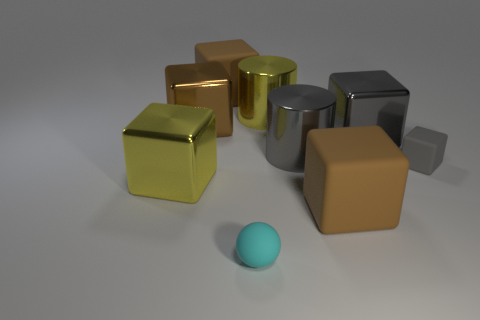Is the material of the large yellow object right of the cyan matte sphere the same as the sphere?
Offer a terse response. No. The small matte object in front of the big brown rubber block that is in front of the yellow shiny thing that is behind the small gray matte object is what shape?
Offer a very short reply. Sphere. How many brown objects are spheres or blocks?
Offer a very short reply. 3. Are there the same number of large yellow cylinders in front of the yellow shiny cylinder and balls that are behind the small gray block?
Ensure brevity in your answer.  Yes. Does the gray metal thing left of the large gray cube have the same shape as the big rubber thing that is in front of the yellow metallic cylinder?
Offer a very short reply. No. Is there any other thing that has the same shape as the tiny cyan thing?
Your answer should be very brief. No. The yellow object that is the same material as the yellow cylinder is what shape?
Keep it short and to the point. Cube. Are there the same number of big gray cylinders on the left side of the large gray shiny cylinder and brown rubber blocks?
Give a very brief answer. No. Is the material of the brown object to the right of the tiny cyan ball the same as the big yellow object that is behind the small gray thing?
Provide a short and direct response. No. The large yellow metal object to the right of the large matte block that is behind the yellow cylinder is what shape?
Offer a very short reply. Cylinder. 